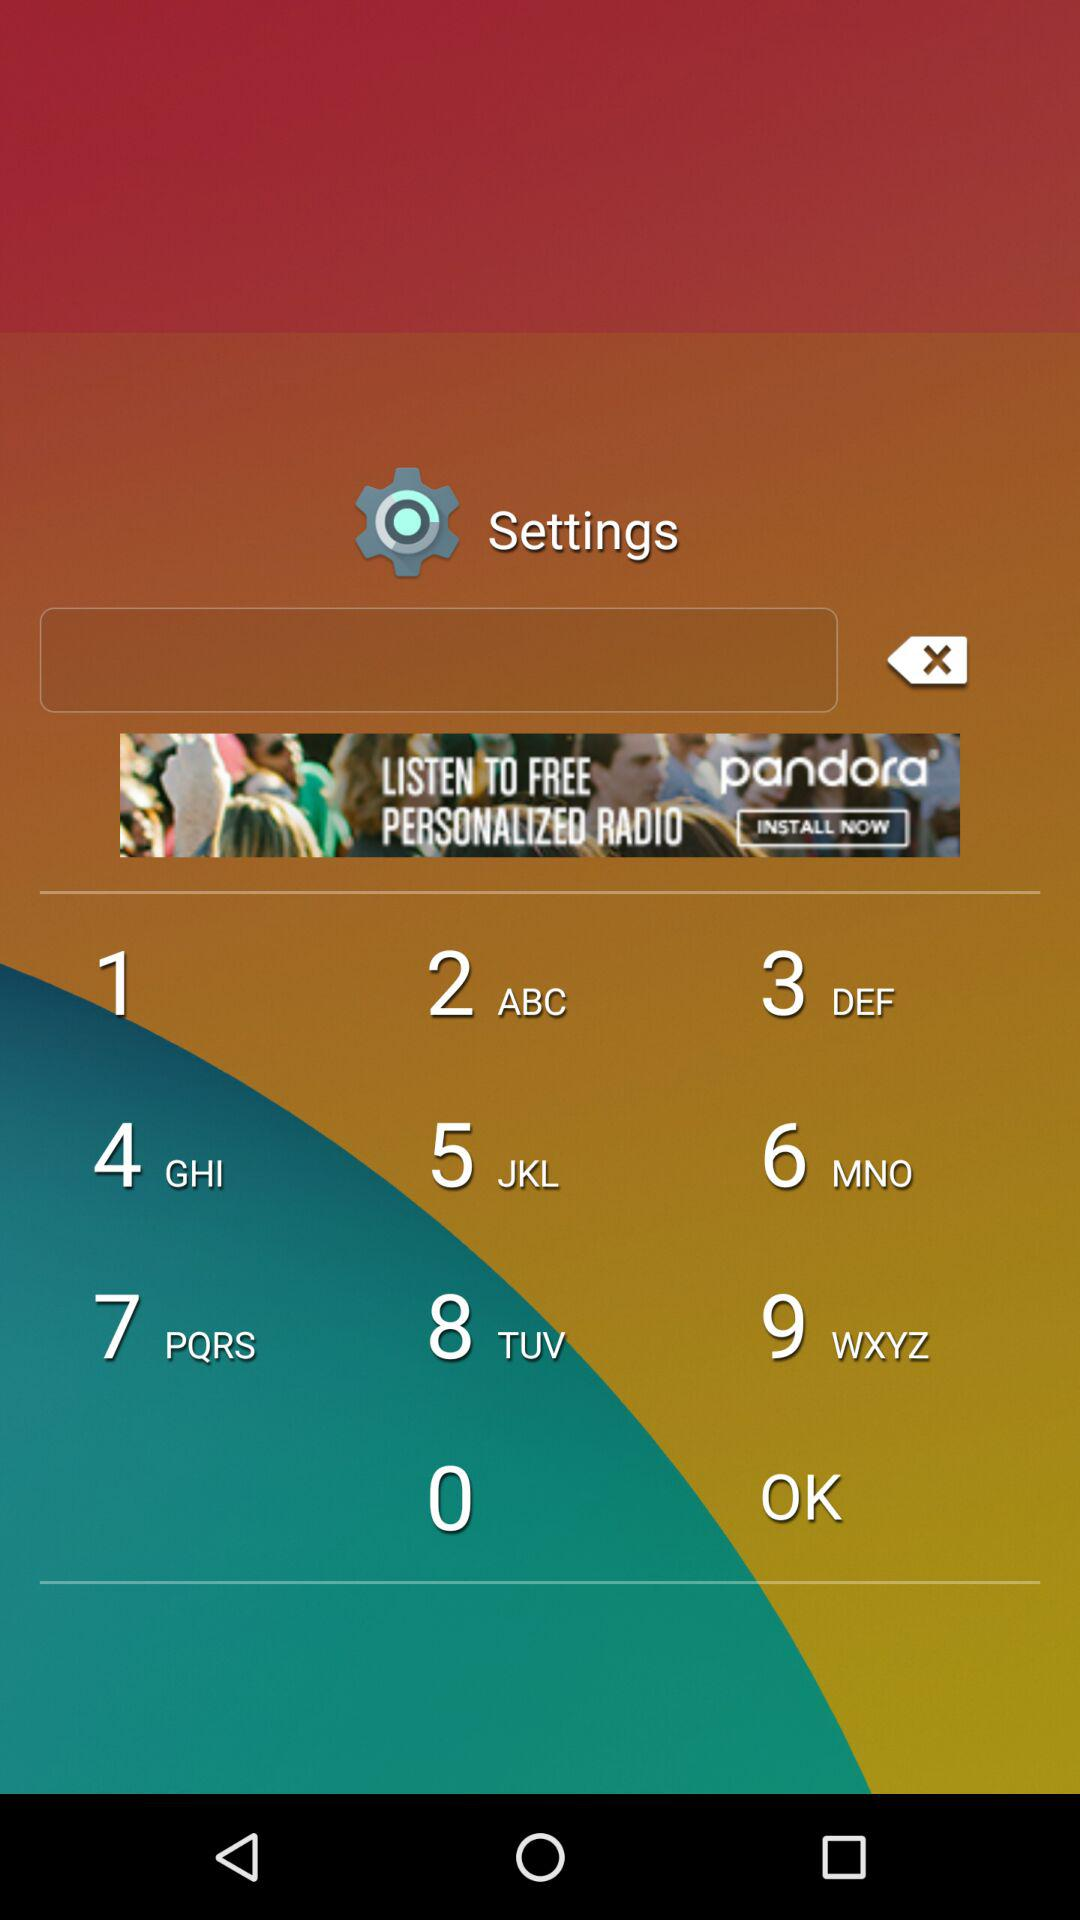Has the user agreed to the terms of service and privacy policy?
When the provided information is insufficient, respond with <no answer>. <no answer> 